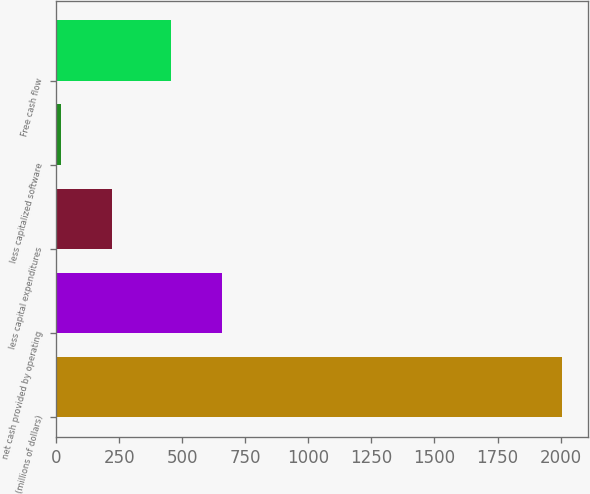<chart> <loc_0><loc_0><loc_500><loc_500><bar_chart><fcel>(millions of dollars)<fcel>net cash provided by operating<fcel>less capital expenditures<fcel>less capitalized software<fcel>Free cash flow<nl><fcel>2007<fcel>655.6<fcel>219.6<fcel>21<fcel>457<nl></chart> 